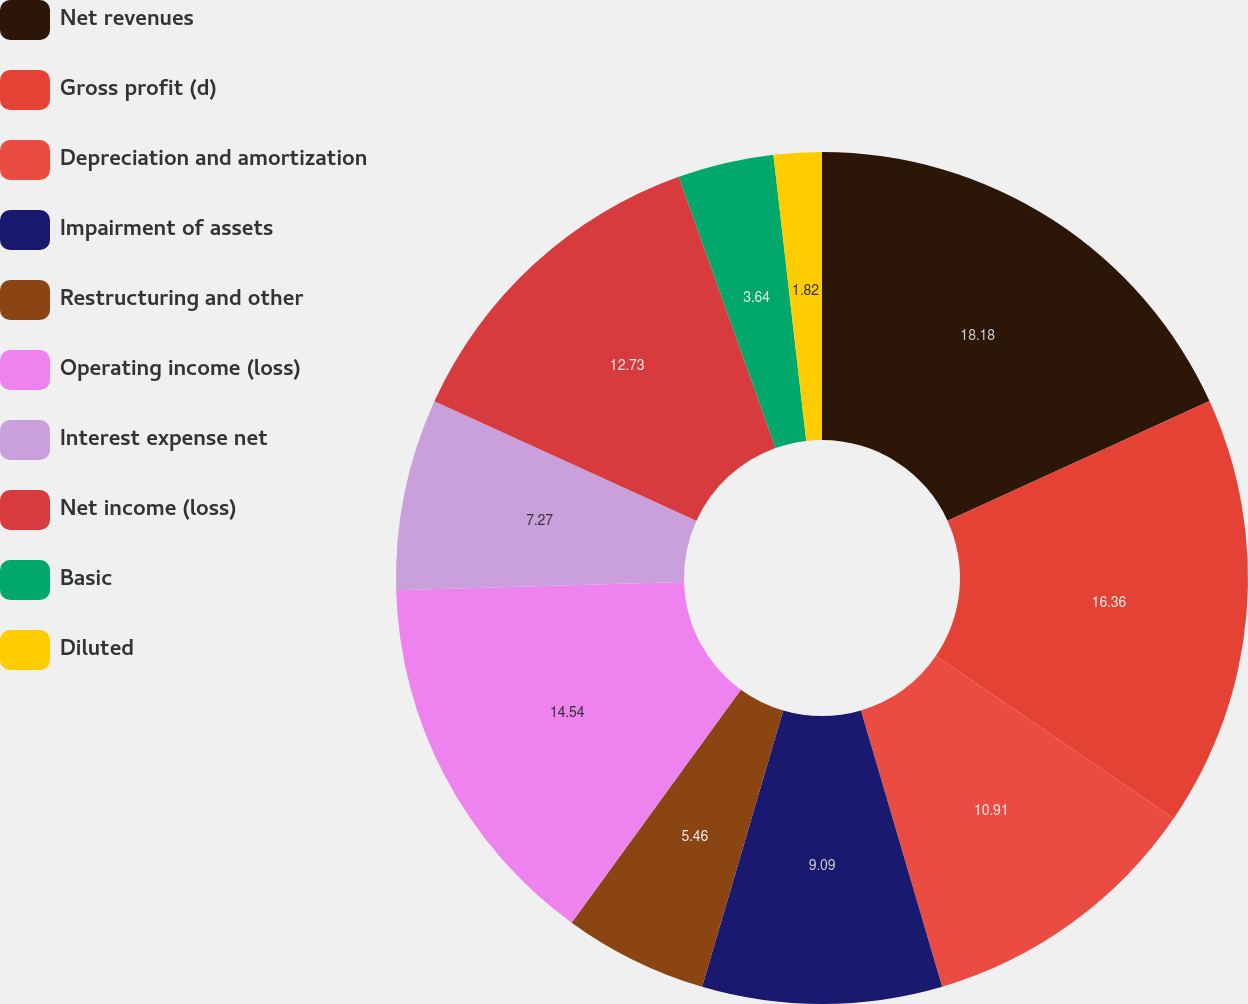<chart> <loc_0><loc_0><loc_500><loc_500><pie_chart><fcel>Net revenues<fcel>Gross profit (d)<fcel>Depreciation and amortization<fcel>Impairment of assets<fcel>Restructuring and other<fcel>Operating income (loss)<fcel>Interest expense net<fcel>Net income (loss)<fcel>Basic<fcel>Diluted<nl><fcel>18.18%<fcel>16.36%<fcel>10.91%<fcel>9.09%<fcel>5.46%<fcel>14.54%<fcel>7.27%<fcel>12.73%<fcel>3.64%<fcel>1.82%<nl></chart> 